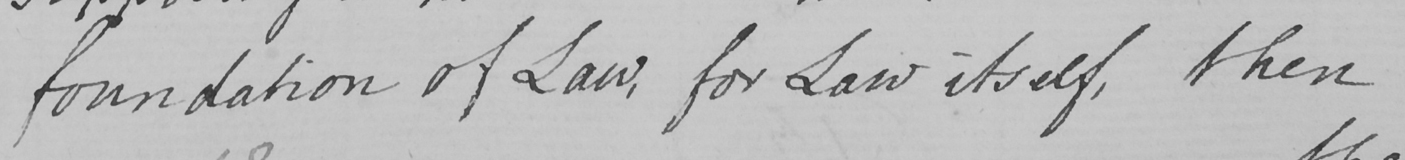Transcribe the text shown in this historical manuscript line. foundation of Law , for Law itself , then 